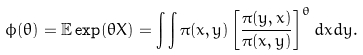<formula> <loc_0><loc_0><loc_500><loc_500>\phi ( \theta ) = \mathbb { E } \exp ( \theta X ) = \int \int \pi ( x , y ) \left [ \frac { \pi ( y , x ) } { \pi ( x , y ) } \right ] ^ { \theta } d x d y .</formula> 